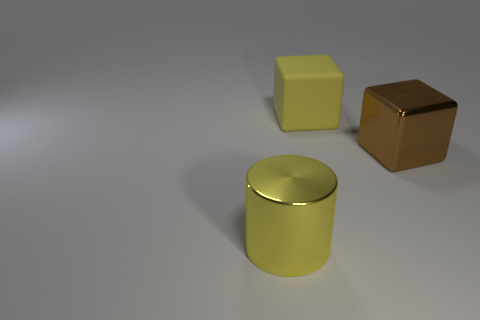Add 3 yellow shiny cylinders. How many objects exist? 6 Subtract all cubes. How many objects are left? 1 Add 3 small red matte cubes. How many small red matte cubes exist? 3 Subtract 0 purple blocks. How many objects are left? 3 Subtract all big blue shiny cylinders. Subtract all big yellow cylinders. How many objects are left? 2 Add 2 large yellow metallic objects. How many large yellow metallic objects are left? 3 